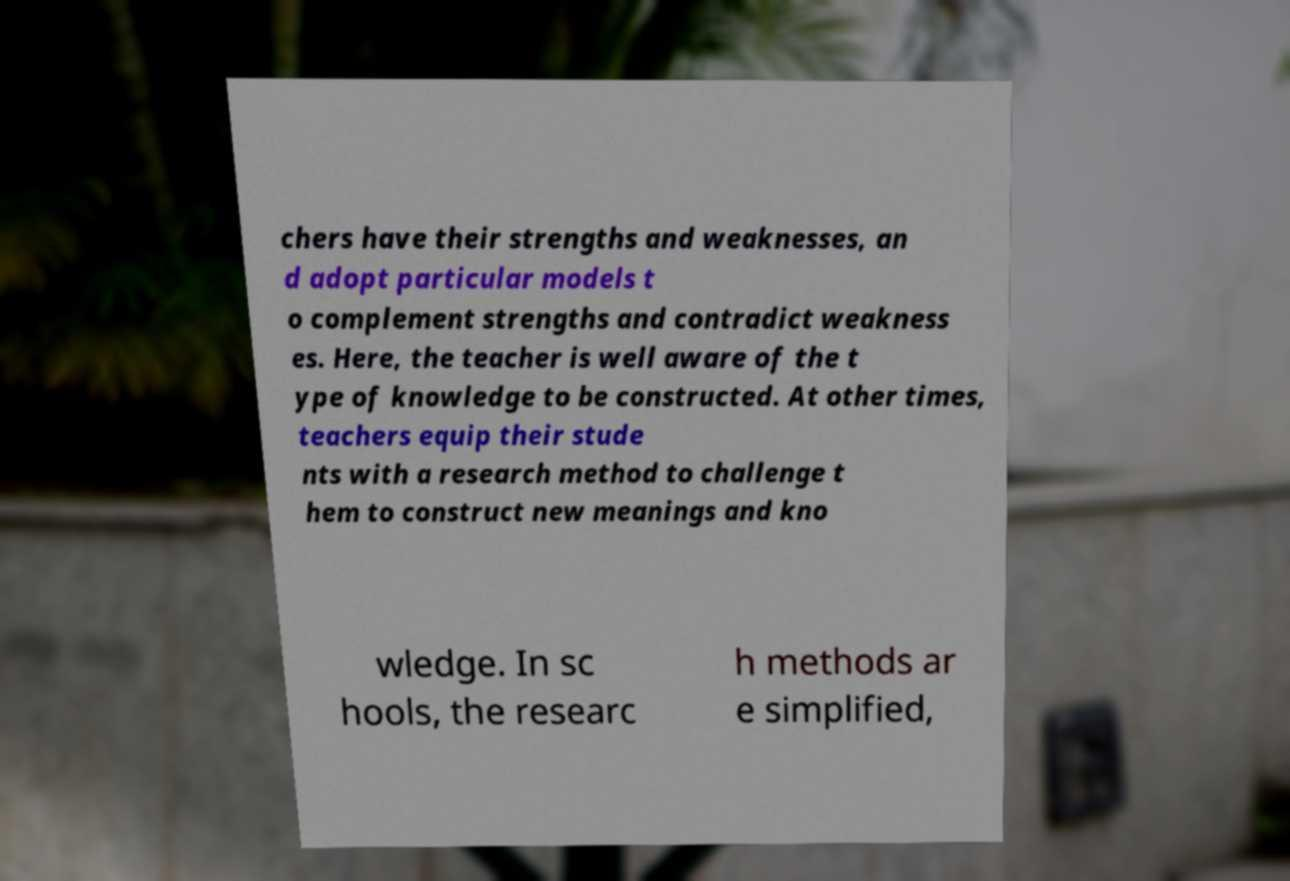Please read and relay the text visible in this image. What does it say? chers have their strengths and weaknesses, an d adopt particular models t o complement strengths and contradict weakness es. Here, the teacher is well aware of the t ype of knowledge to be constructed. At other times, teachers equip their stude nts with a research method to challenge t hem to construct new meanings and kno wledge. In sc hools, the researc h methods ar e simplified, 